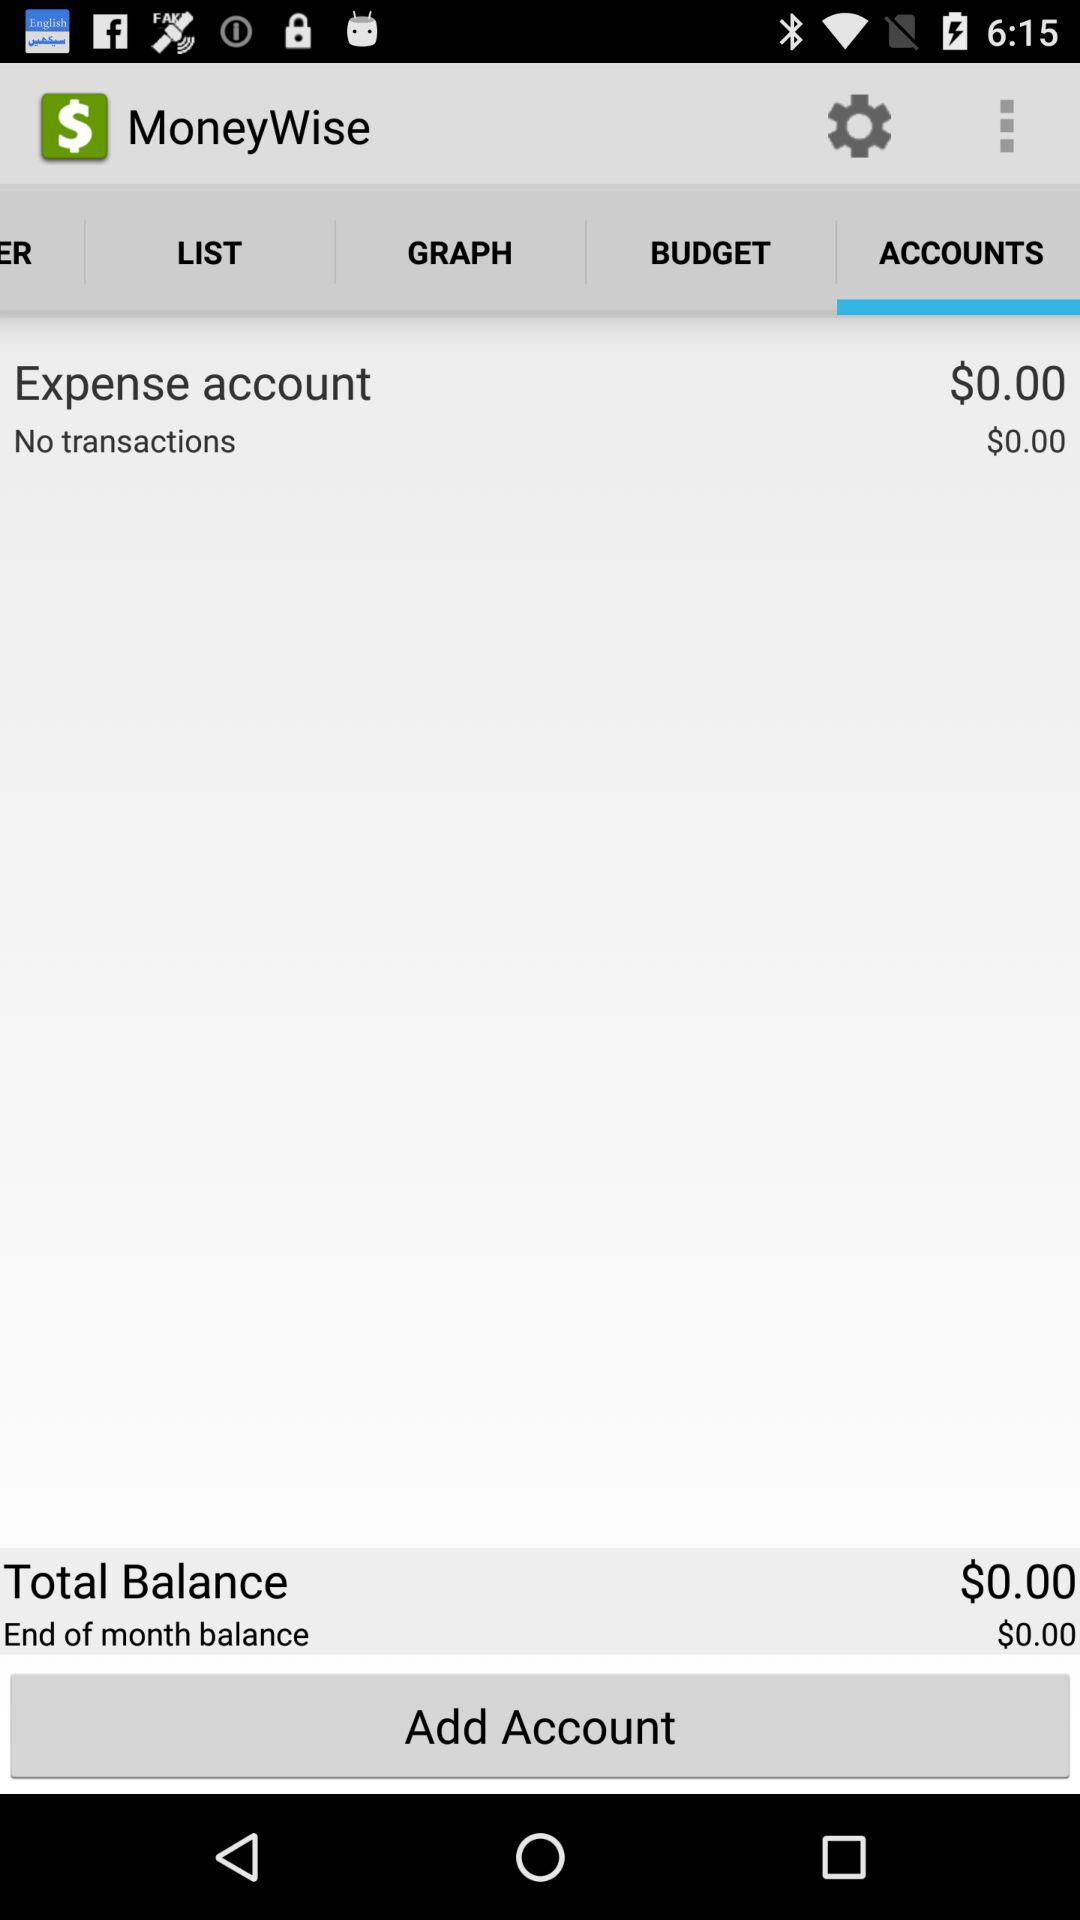Which tab is selected? The selected tab is "ACCOUNTS". 